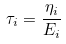<formula> <loc_0><loc_0><loc_500><loc_500>\tau _ { i } = \frac { \eta _ { i } } { E _ { i } }</formula> 